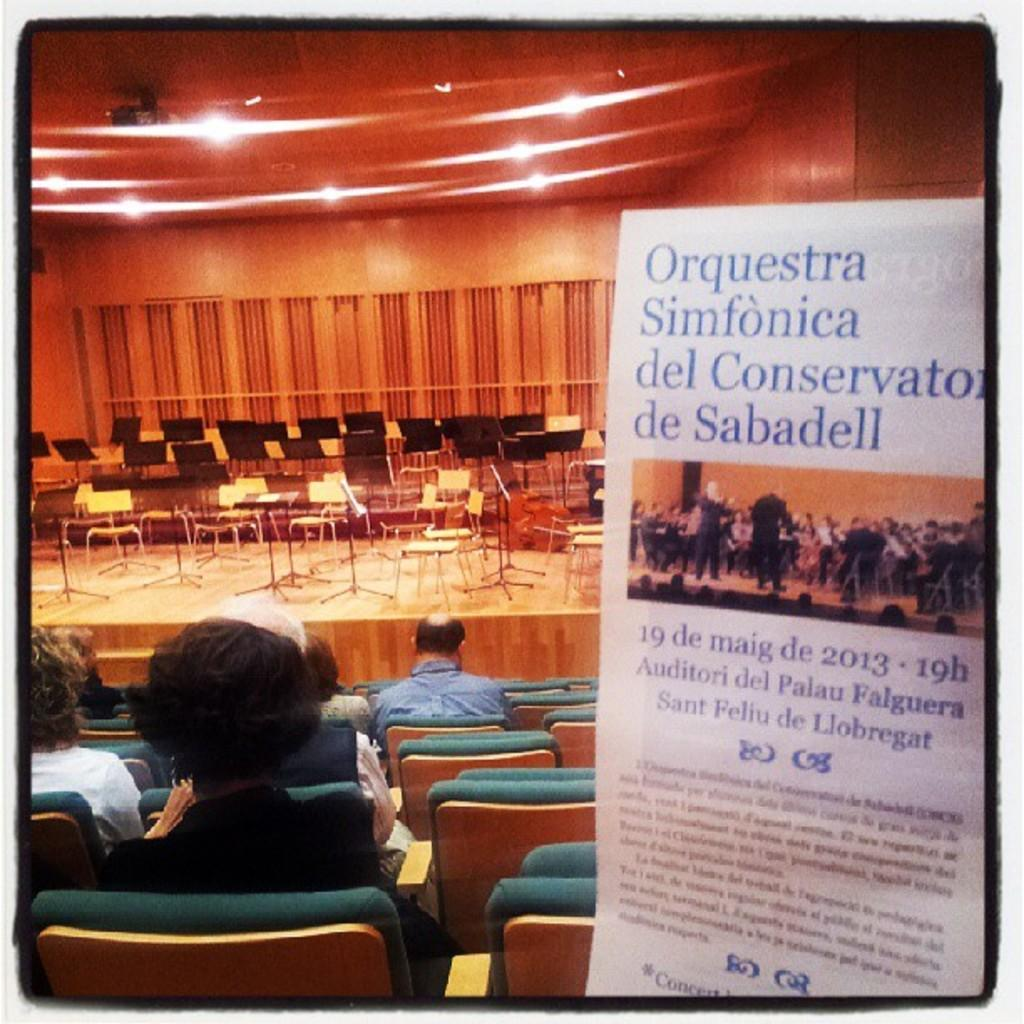What are the people in the image doing? The people in the image are sitting on chairs. Can you describe the chairs in the image? There are chairs in the foreground and background of the image. What is visible in the background of the image? There is a banner, lights, and a wall visible in the background of the image. What type of engine is visible in the image? There is no engine present in the image. What type of line is being used by the people in the image? The people in the image are not using any lines; they are sitting on chairs. 